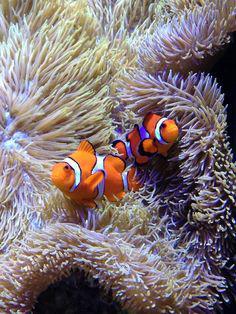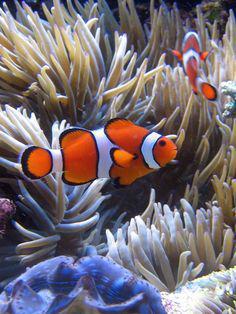The first image is the image on the left, the second image is the image on the right. For the images shown, is this caption "The left and right image contains the same number of fish." true? Answer yes or no. Yes. 